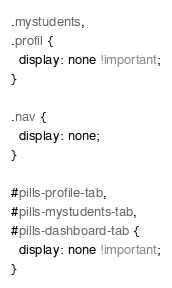<code> <loc_0><loc_0><loc_500><loc_500><_CSS_>.mystudents,
.profil {
  display: none !important;
}

.nav {
  display: none;
}

#pills-profile-tab,
#pills-mystudents-tab,
#pills-dashboard-tab {
  display: none !important;
}

</code> 